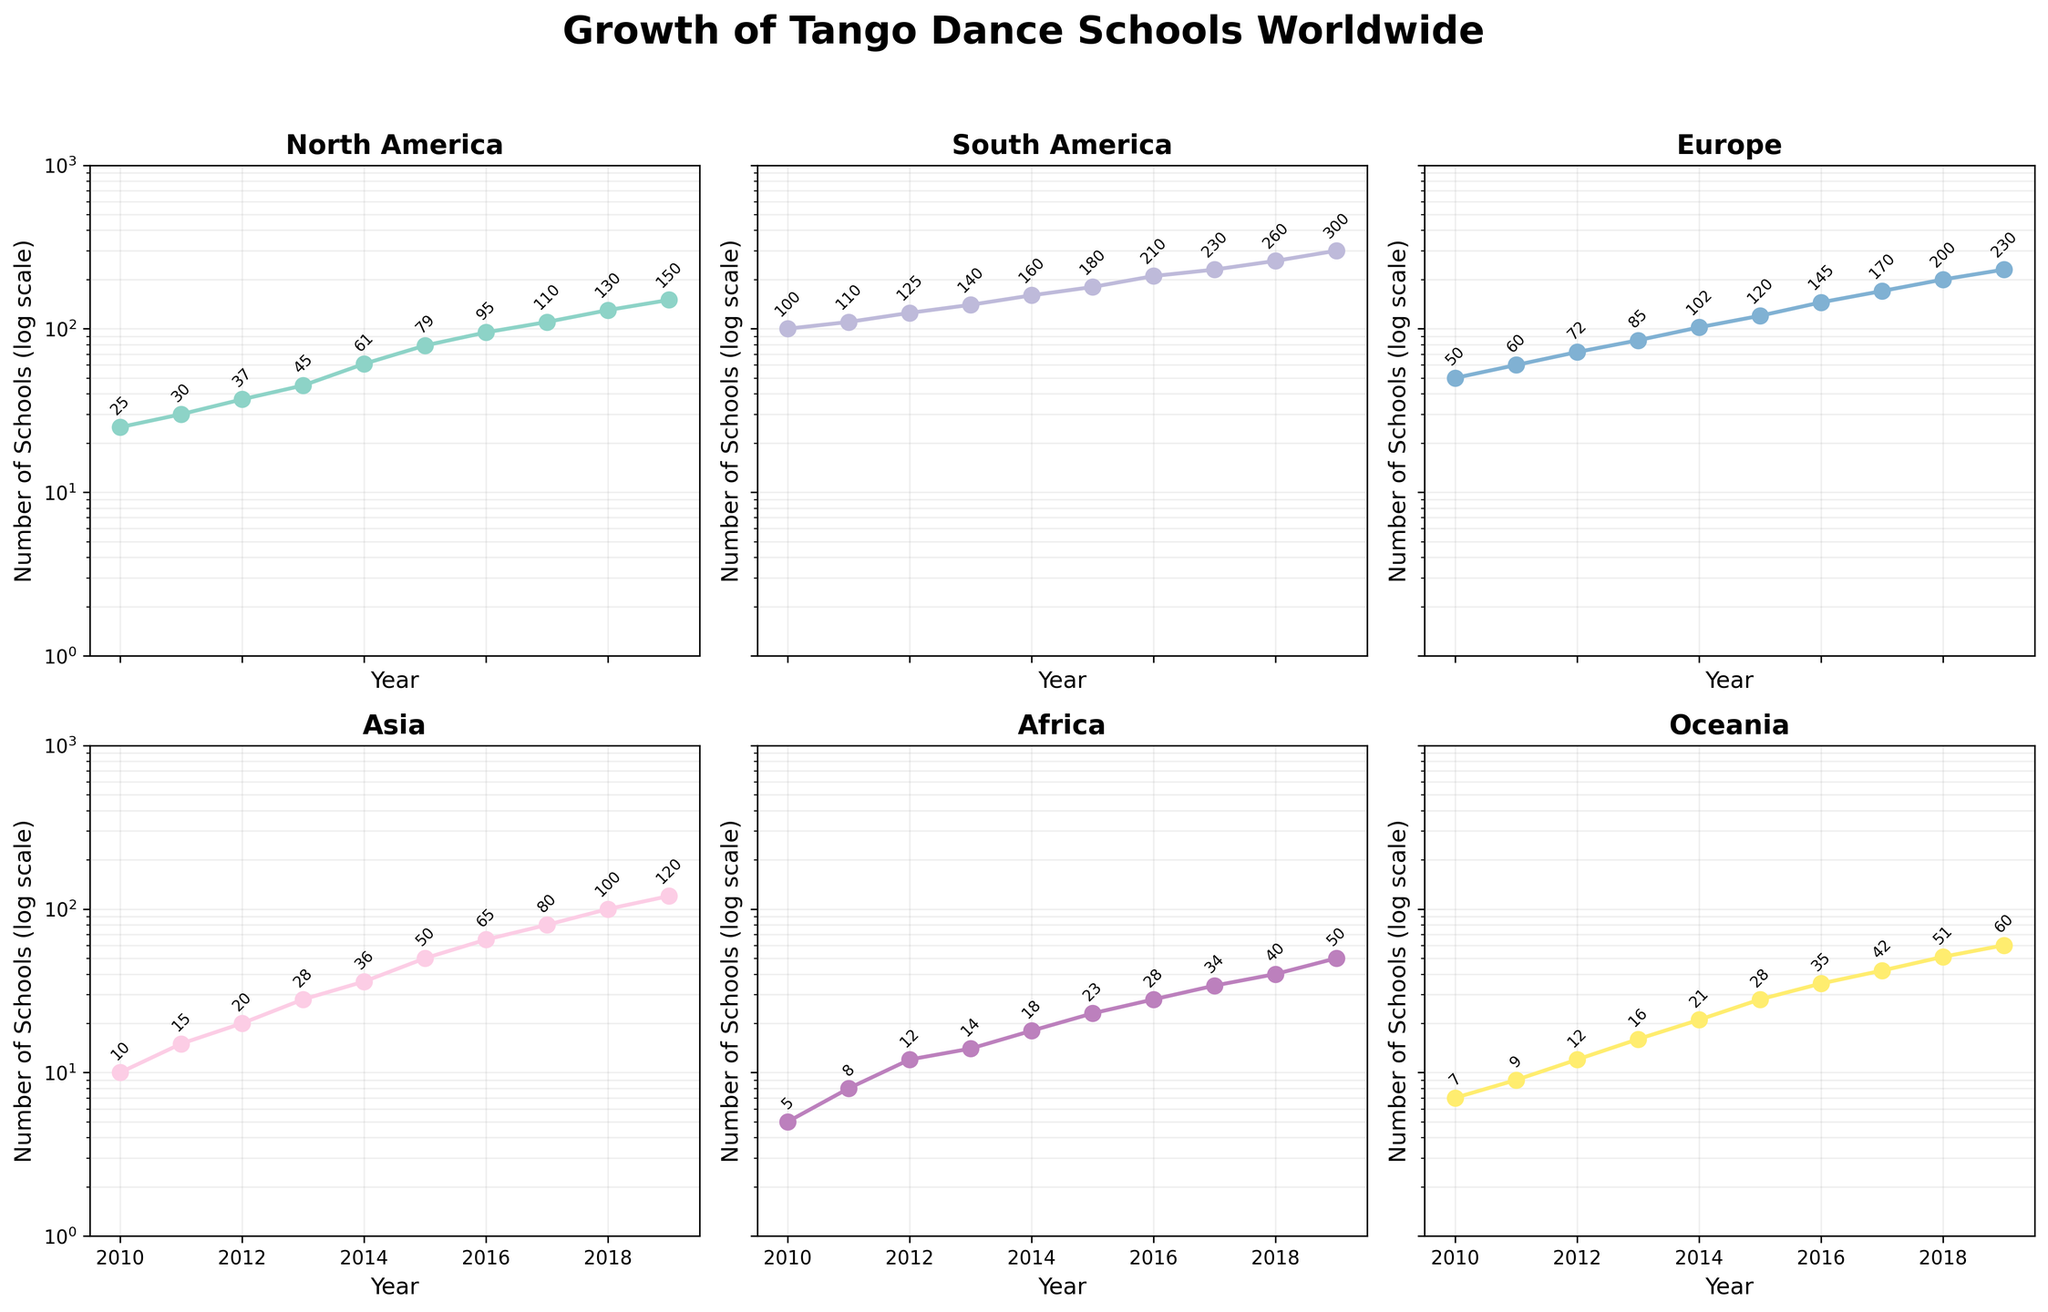what is the title of the figure? The title of the figure is typically displayed at the top of the chart. For this figure, the title is "Growth of Tango Dance Schools Worldwide" which encapsulates the essence of the data being visualized.
Answer: Growth of Tango Dance Schools Worldwide Which continent had the highest number of tango dance schools in 2019? To find this, we examine the highest data point in each subplot for the year 2019. Among North America, South America, Europe, Asia, Africa, and Oceania, South America has the highest value at 300.
Answer: South America What trend can be observed for tango dance schools in Asia between 2010 and 2019? By observing the line plotted for Asia, it can be seen that there is a consistent increase in the number of tango dance schools from 10 in 2010 to 120 in 2019. This represents a significant growth over the years.
Answer: Consistent increase How does the growth in the number of tango dance schools in Europe compare to that in North America from 2010 to 2019? The data shows a consistent increase for both continents; however, upon closer inspection, Europe shows an increase from 50 to 230 schools, while North America shows an increase from 25 to 150 schools. Europe had both a larger absolute and relative increase.
Answer: Europe's growth was larger What was the approximate number of tango dance schools in Oceania in 2014? By locating the year 2014 on the x-axis of the Oceania subplot, the corresponding y-axis value, which is marked on the curve and annotated, is 21 schools.
Answer: 21 Which continent had the smallest growth in the number of tango dance schools from 2010 to 2019? By comparing the growth across subplots, Africa shows the smallest increase with 5 schools in 2010 and 50 in 2019, which is still a significant percentage increase but the smallest in absolute terms.
Answer: Africa What is the general shape of the plot showing the number of tango dance schools in South America over the years? The plot for South America starts from a high base and shows a steady, nearly linear upward trend, indicating a strong and steady increase in the number of schools.
Answer: Steadily increasing How does the spread of the number of dance schools in different continents in 2010 compare to 2019? In 2010, the number of schools ranges from 5 in Africa to 100 in South America, showing a wide disparity. By 2019, the disparity increases with the counts ranging from 50 in Africa to 300 in South America.
Answer: Spread increased What is the pattern of change for the number of dance schools in Africa from 2010 to 2019? The graph of Africa shows a gradual increase over time, starting from 5 schools in 2010 and reaching 50 by 2019, indicating steady growth.
Answer: Gradual increase 